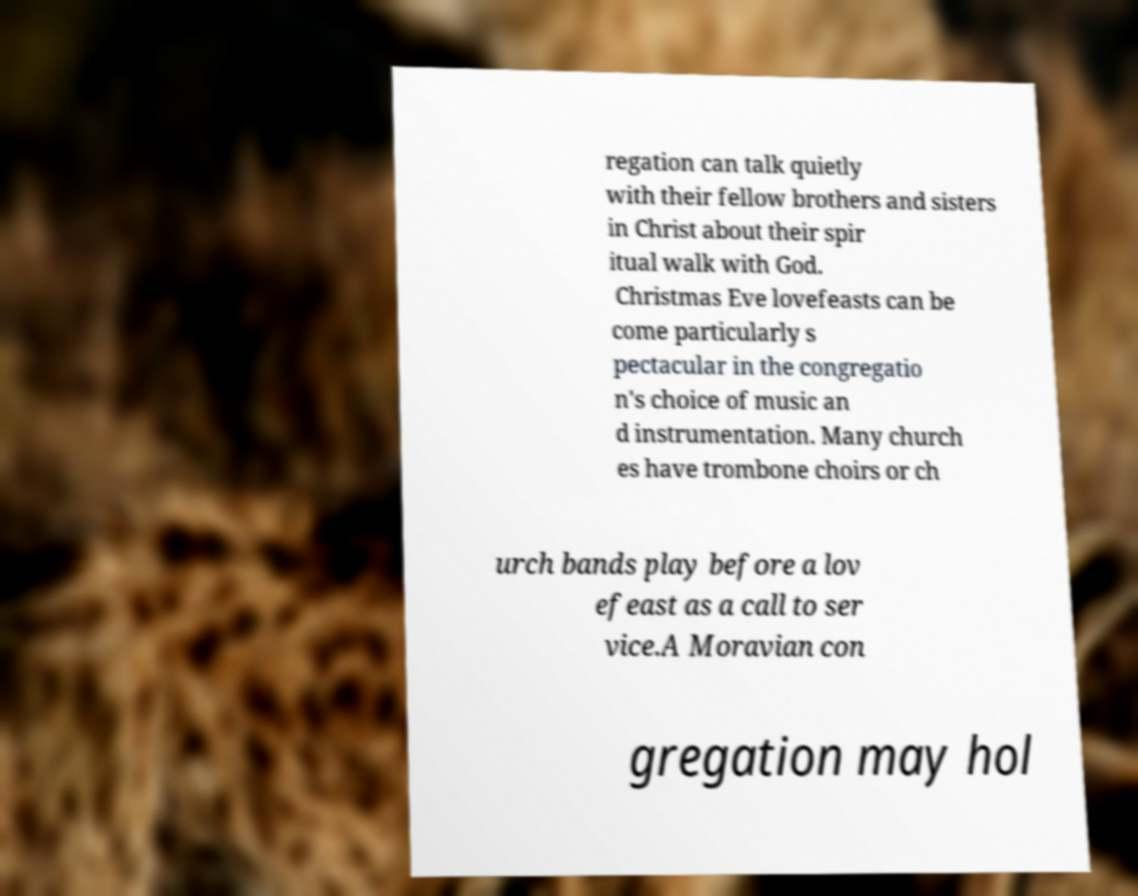Please identify and transcribe the text found in this image. regation can talk quietly with their fellow brothers and sisters in Christ about their spir itual walk with God. Christmas Eve lovefeasts can be come particularly s pectacular in the congregatio n's choice of music an d instrumentation. Many church es have trombone choirs or ch urch bands play before a lov efeast as a call to ser vice.A Moravian con gregation may hol 